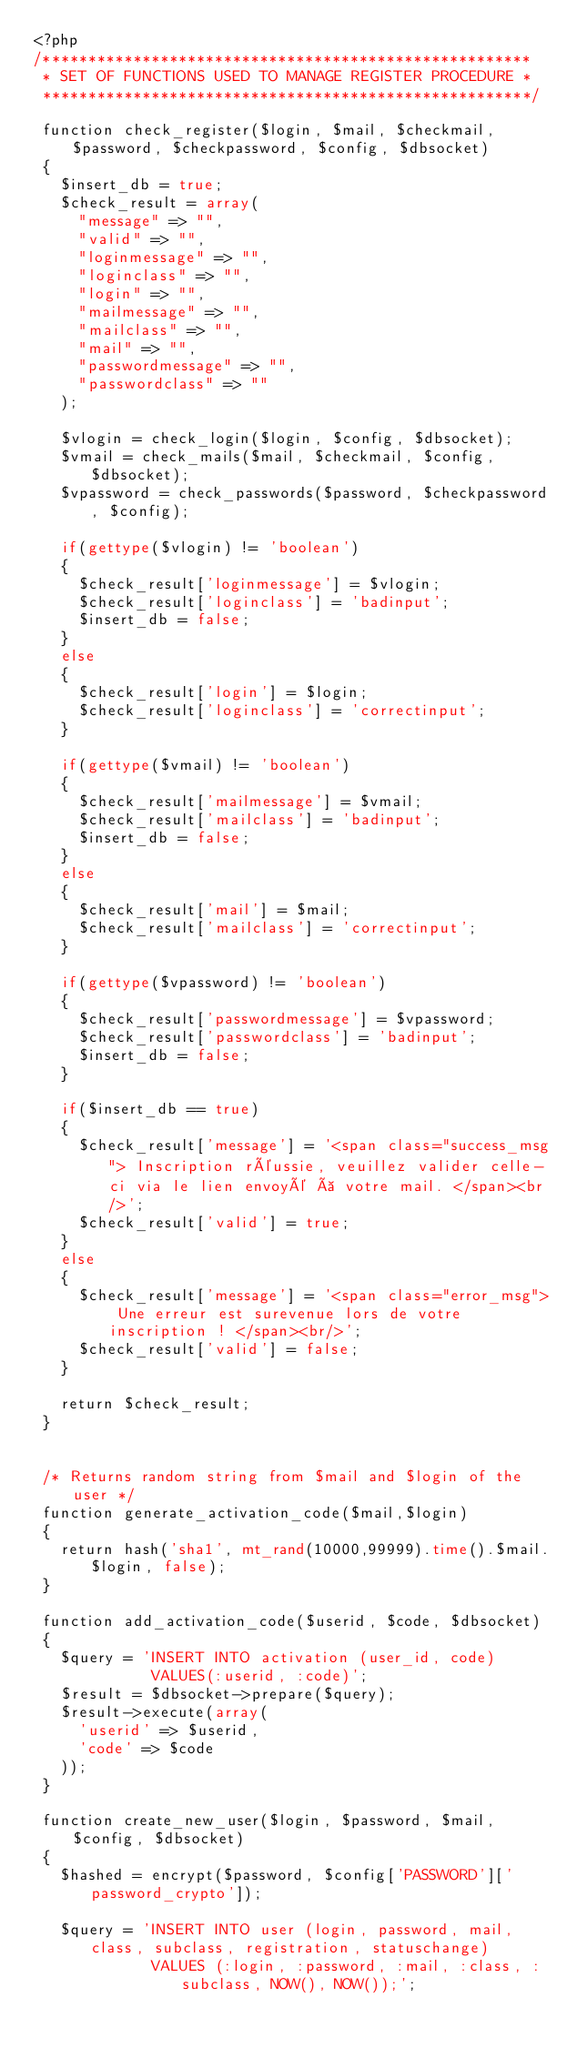<code> <loc_0><loc_0><loc_500><loc_500><_PHP_><?php
/******************************************************
 * SET OF FUNCTIONS USED TO MANAGE REGISTER PROCEDURE *
 ******************************************************/

 function check_register($login, $mail, $checkmail, $password, $checkpassword, $config, $dbsocket)
 {
   $insert_db = true;
   $check_result = array(
     "message" => "",
     "valid" => "",
     "loginmessage" => "",
     "loginclass" => "",
     "login" => "",
     "mailmessage" => "",
     "mailclass" => "",
     "mail" => "",
     "passwordmessage" => "",
     "passwordclass" => ""
   );

   $vlogin = check_login($login, $config, $dbsocket);
   $vmail = check_mails($mail, $checkmail, $config, $dbsocket);
   $vpassword = check_passwords($password, $checkpassword, $config);

   if(gettype($vlogin) != 'boolean')
   {
     $check_result['loginmessage'] = $vlogin;
     $check_result['loginclass'] = 'badinput';
     $insert_db = false;
   }
   else
   {
     $check_result['login'] = $login;
     $check_result['loginclass'] = 'correctinput';
   }

   if(gettype($vmail) != 'boolean')
   {
     $check_result['mailmessage'] = $vmail;
     $check_result['mailclass'] = 'badinput';
     $insert_db = false;
   }
   else
   {
     $check_result['mail'] = $mail;
     $check_result['mailclass'] = 'correctinput';
   }

   if(gettype($vpassword) != 'boolean')
   {
     $check_result['passwordmessage'] = $vpassword;
     $check_result['passwordclass'] = 'badinput';
     $insert_db = false;
   }

   if($insert_db == true)
   {
     $check_result['message'] = '<span class="success_msg"> Inscription réussie, veuillez valider celle-ci via le lien envoyé à votre mail. </span><br/>';
     $check_result['valid'] = true;
   }
   else
   {
     $check_result['message'] = '<span class="error_msg"> Une erreur est surevenue lors de votre inscription ! </span><br/>';
     $check_result['valid'] = false;
   }

   return $check_result;
 }


 /* Returns random string from $mail and $login of the user */
 function generate_activation_code($mail,$login)
 {
   return hash('sha1', mt_rand(10000,99999).time().$mail.$login, false);
 }

 function add_activation_code($userid, $code, $dbsocket)
 {
   $query = 'INSERT INTO activation (user_id, code)
             VALUES(:userid, :code)';
   $result = $dbsocket->prepare($query);
   $result->execute(array(
     'userid' => $userid,
     'code' => $code
   ));
 }

 function create_new_user($login, $password, $mail, $config, $dbsocket)
 {
   $hashed = encrypt($password, $config['PASSWORD']['password_crypto']);

   $query = 'INSERT INTO user (login, password, mail, class, subclass, registration, statuschange)
             VALUES (:login, :password, :mail, :class, :subclass, NOW(), NOW());';</code> 